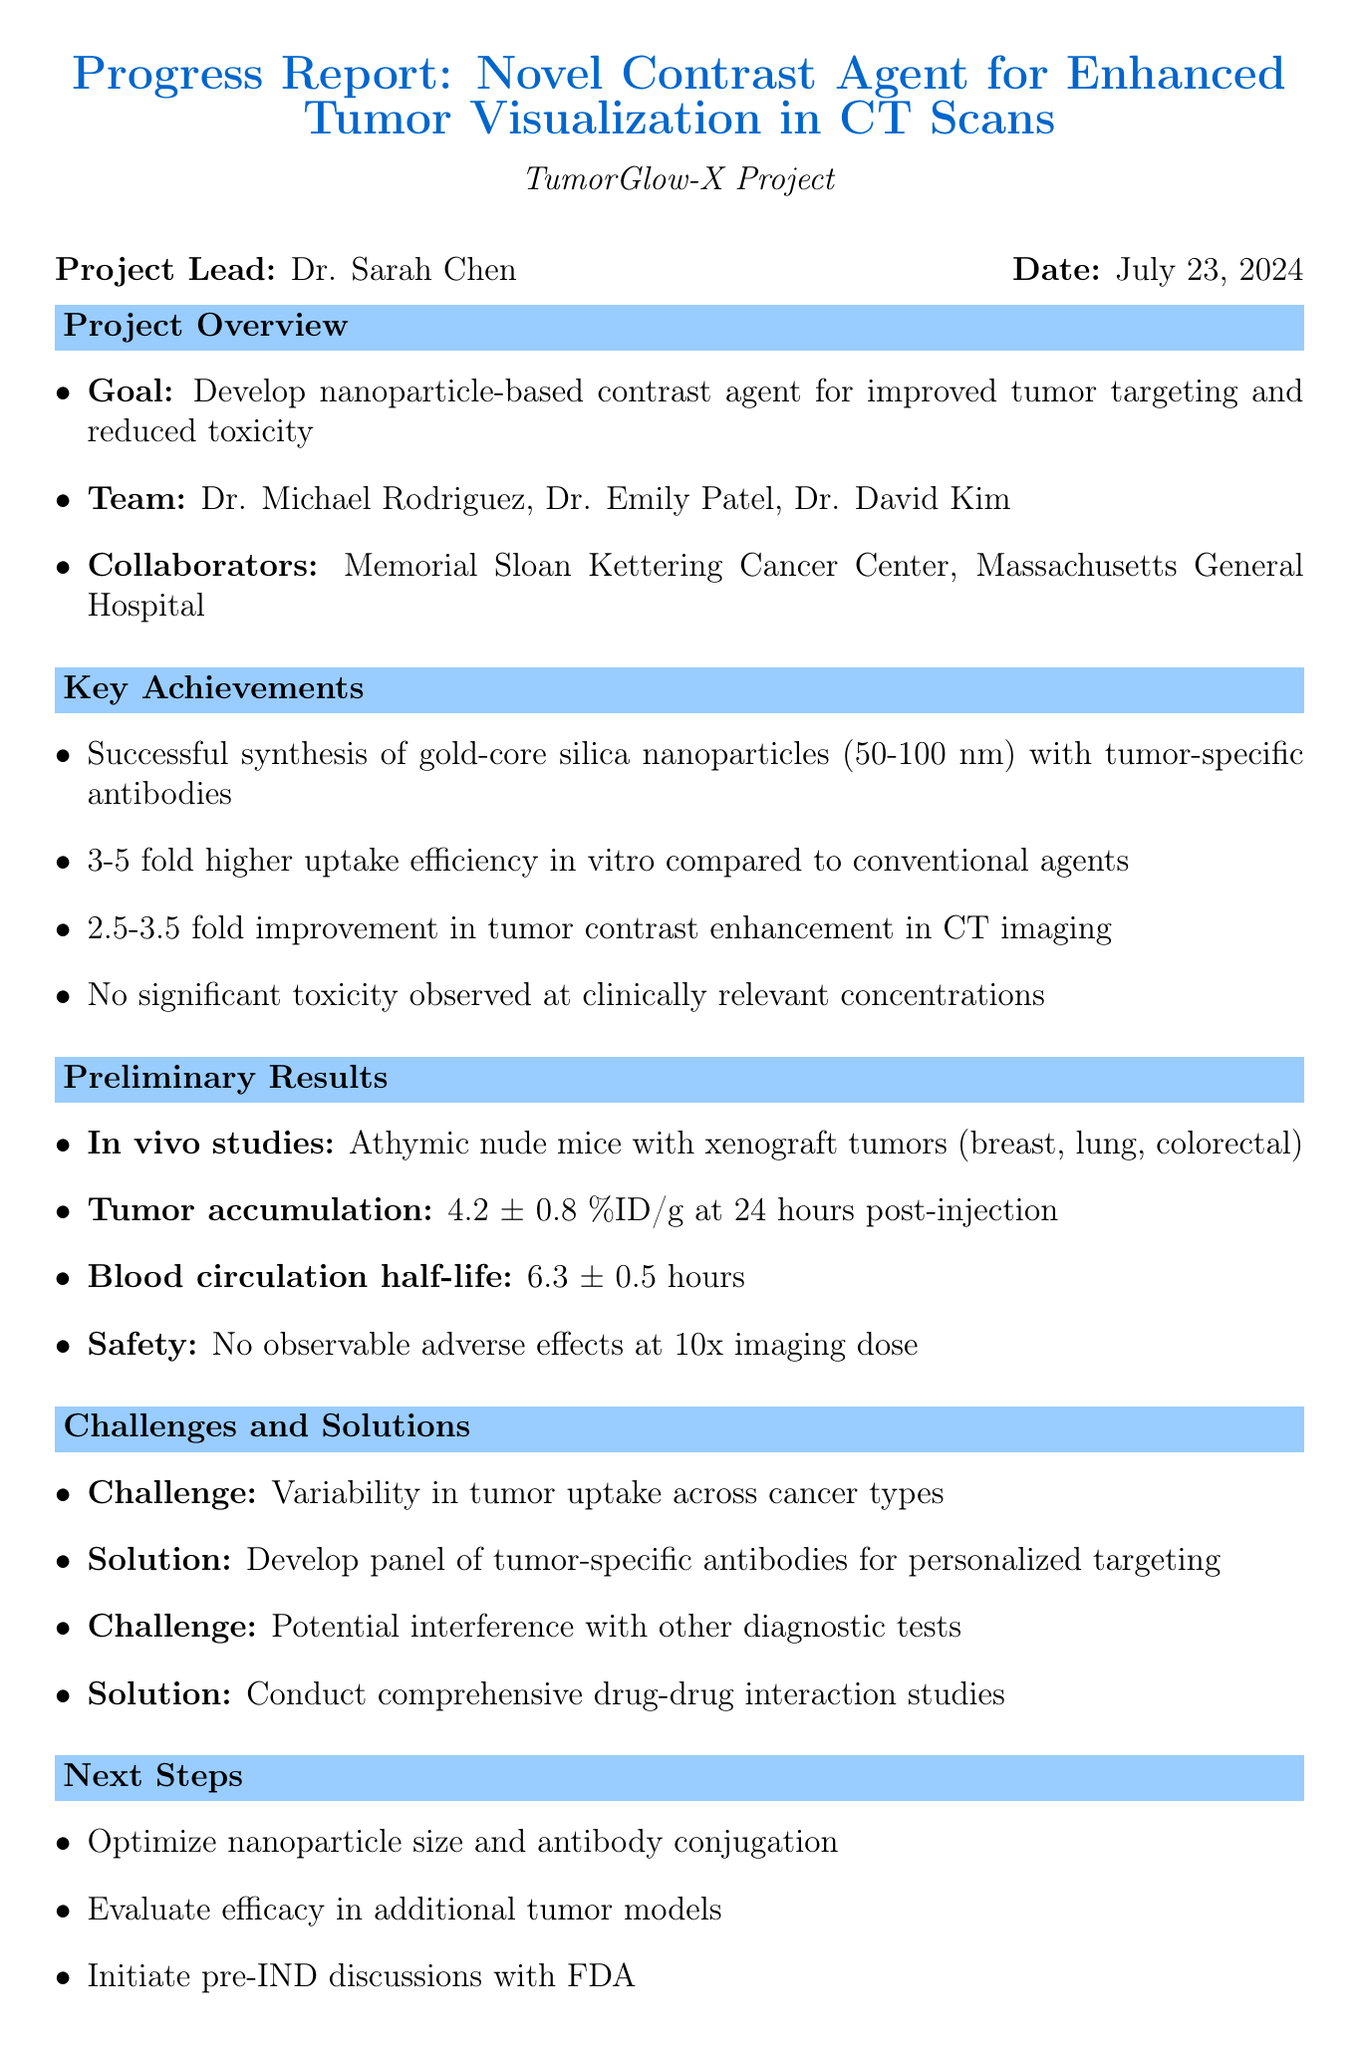What is the project name? The project name is stated prominently in the document's title section, which is TumorGlow-X.
Answer: TumorGlow-X Who is the lead researcher? The lead researcher is mentioned in the project overview section as Dr. Sarah Chen.
Answer: Dr. Sarah Chen What is the size range of the nanoparticles developed? The size range is indicated in the development progress section under nanoparticle synthesis, which is 50-100 nm.
Answer: 50-100 nm What improvement in tumor contrast enhancement was observed in preliminary results? The document specifies that there was a 2.5-3.5 fold improvement compared to iopromide.
Answer: 2.5-3.5 fold What is the blood circulation half-life of the contrast agent? The blood circulation half-life is found in the biodistribution section of the preliminary results, which states 6.3 ± 0.5 hours.
Answer: 6.3 ± 0.5 hours What challenge is associated with the tumor uptake variability? The specific challenge is noted in the challenges section as variability in tumor uptake across different cancer types.
Answer: Variability in tumor uptake across cancer types What is the additional funding needed for clinical trial initiation? The amount of additional funding needed is clearly stated in the funding status section, which is $1.8 million.
Answer: $1.8 million When is the IND submission planned? The timeline section mentions that the IND submission is planned for Q2 2024.
Answer: Q2 2024 What is the next report due date? The due date for the next report is provided in the conclusion section, which is June 30, 2023.
Answer: June 30, 2023 